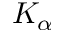Convert formula to latex. <formula><loc_0><loc_0><loc_500><loc_500>K _ { \alpha }</formula> 